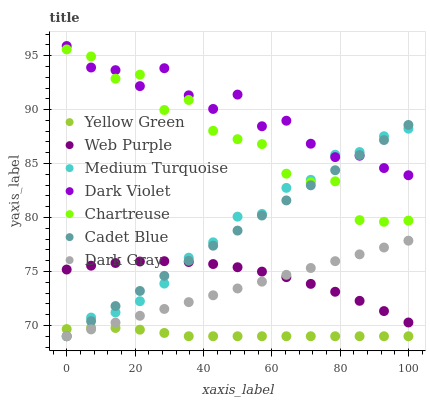Does Yellow Green have the minimum area under the curve?
Answer yes or no. Yes. Does Dark Violet have the maximum area under the curve?
Answer yes or no. Yes. Does Web Purple have the minimum area under the curve?
Answer yes or no. No. Does Web Purple have the maximum area under the curve?
Answer yes or no. No. Is Dark Gray the smoothest?
Answer yes or no. Yes. Is Chartreuse the roughest?
Answer yes or no. Yes. Is Yellow Green the smoothest?
Answer yes or no. No. Is Yellow Green the roughest?
Answer yes or no. No. Does Cadet Blue have the lowest value?
Answer yes or no. Yes. Does Web Purple have the lowest value?
Answer yes or no. No. Does Dark Violet have the highest value?
Answer yes or no. Yes. Does Web Purple have the highest value?
Answer yes or no. No. Is Yellow Green less than Web Purple?
Answer yes or no. Yes. Is Dark Violet greater than Yellow Green?
Answer yes or no. Yes. Does Medium Turquoise intersect Chartreuse?
Answer yes or no. Yes. Is Medium Turquoise less than Chartreuse?
Answer yes or no. No. Is Medium Turquoise greater than Chartreuse?
Answer yes or no. No. Does Yellow Green intersect Web Purple?
Answer yes or no. No. 